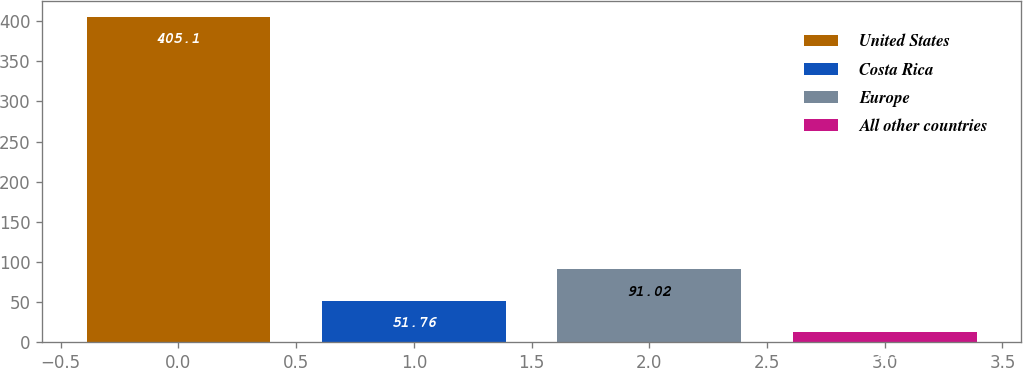Convert chart to OTSL. <chart><loc_0><loc_0><loc_500><loc_500><bar_chart><fcel>United States<fcel>Costa Rica<fcel>Europe<fcel>All other countries<nl><fcel>405.1<fcel>51.76<fcel>91.02<fcel>12.5<nl></chart> 